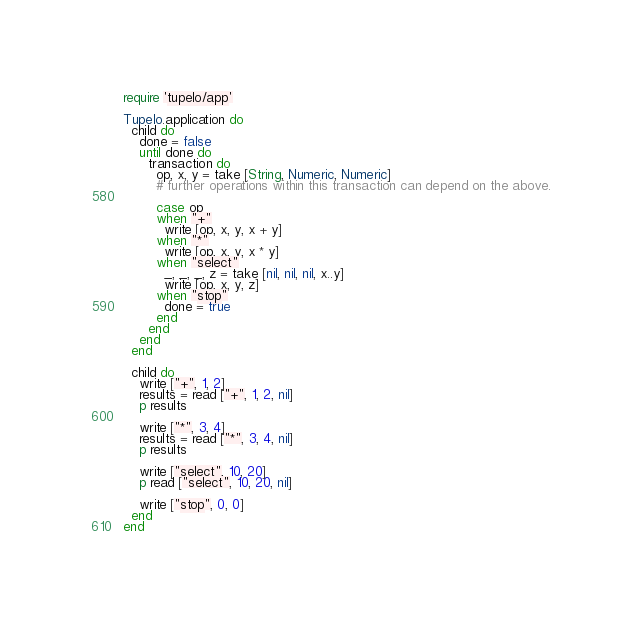Convert code to text. <code><loc_0><loc_0><loc_500><loc_500><_Ruby_>require 'tupelo/app'

Tupelo.application do
  child do
    done = false
    until done do
      transaction do
        op, x, y = take [String, Numeric, Numeric]
        # further operations within this transaction can depend on the above.
        
        case op
        when "+"
          write [op, x, y, x + y]
        when "*"
          write [op, x, y, x * y]
        when "select"
          _, _, _, z = take [nil, nil, nil, x..y]
          write [op, x, y, z]
        when "stop"
          done = true
        end
      end
    end
  end

  child do
    write ["+", 1, 2]
    results = read ["+", 1, 2, nil]
    p results

    write ["*", 3, 4]
    results = read ["*", 3, 4, nil]
    p results

    write ["select", 10, 20]
    p read ["select", 10, 20, nil]
    
    write ["stop", 0, 0]
  end
end
</code> 